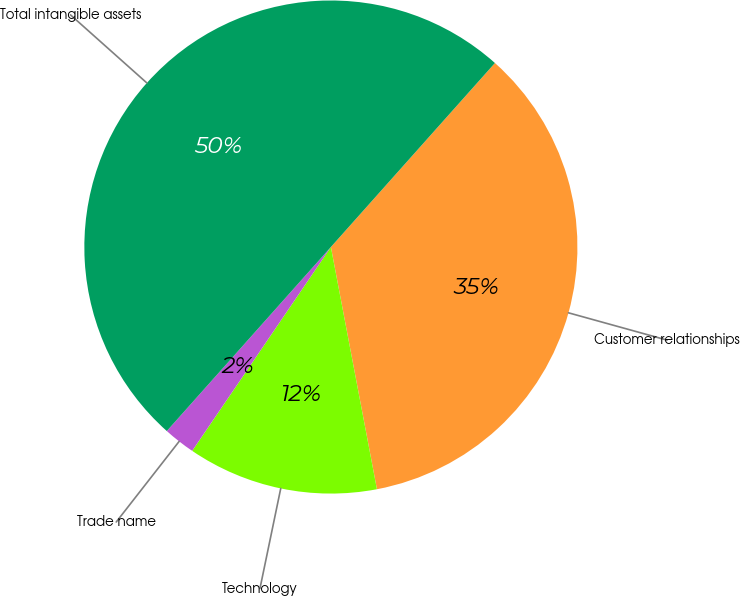<chart> <loc_0><loc_0><loc_500><loc_500><pie_chart><fcel>Customer relationships<fcel>Technology<fcel>Trade name<fcel>Total intangible assets<nl><fcel>35.42%<fcel>12.5%<fcel>2.08%<fcel>50.0%<nl></chart> 